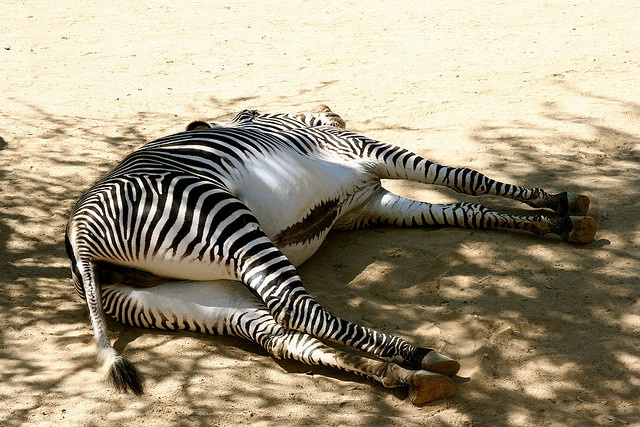Describe the objects in this image and their specific colors. I can see a zebra in lightyellow, black, darkgray, gray, and ivory tones in this image. 